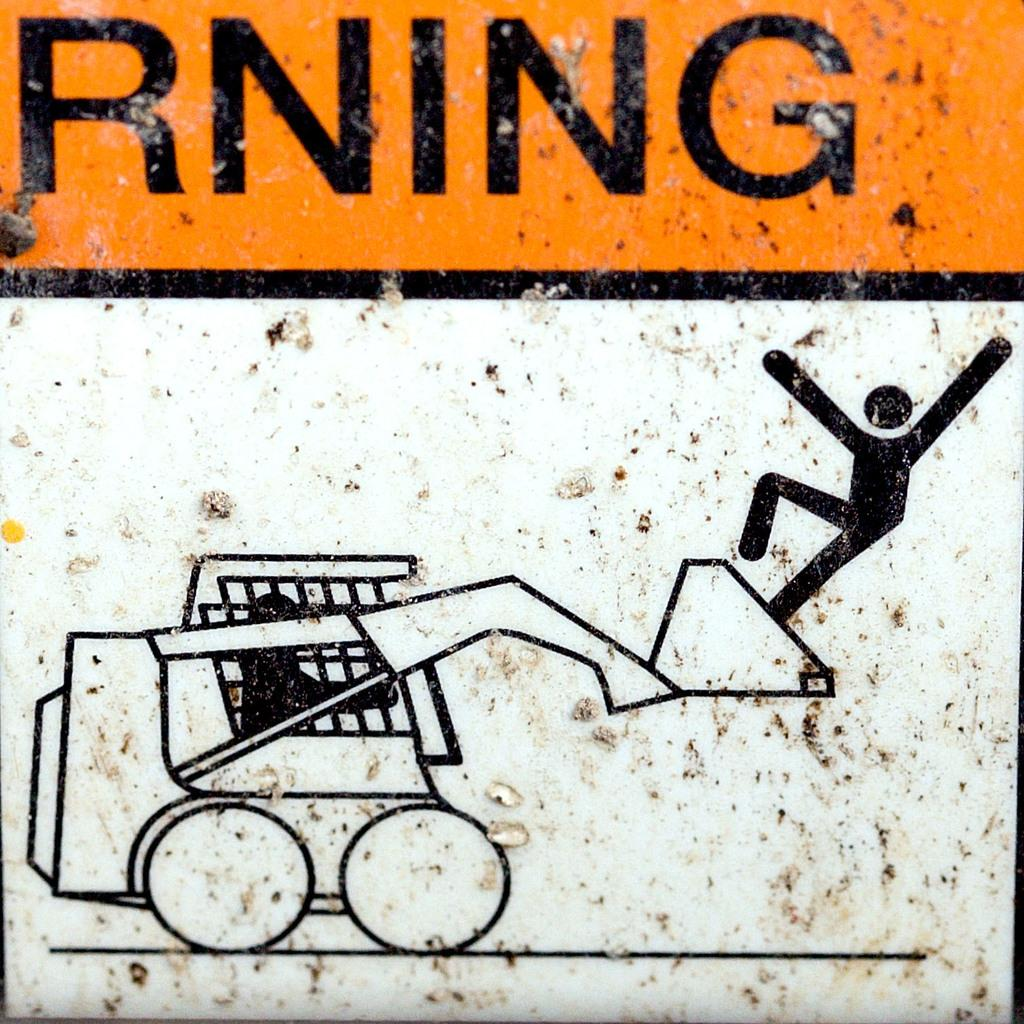What can be seen in the image? There are pictures and text in the image. What is the relationship between the pictures and text in the image? The pictures and text are on a surface together. Can you describe the pictures in the image? Unfortunately, the provided facts do not give any details about the pictures themselves. How many pets are visible in the image? There are no pets present in the image. What type of jewel is featured in the image? There is no jewel present in the image. 